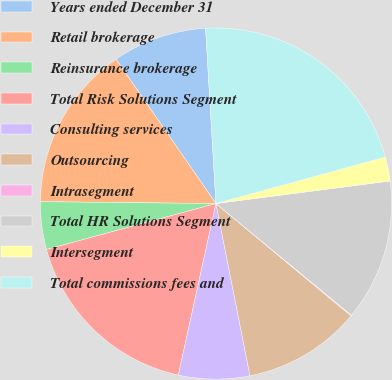Convert chart. <chart><loc_0><loc_0><loc_500><loc_500><pie_chart><fcel>Years ended December 31<fcel>Retail brokerage<fcel>Reinsurance brokerage<fcel>Total Risk Solutions Segment<fcel>Consulting services<fcel>Outsourcing<fcel>Intrasegment<fcel>Total HR Solutions Segment<fcel>Intersegment<fcel>Total commissions fees and<nl><fcel>8.7%<fcel>15.19%<fcel>4.38%<fcel>17.35%<fcel>6.54%<fcel>10.86%<fcel>0.06%<fcel>13.03%<fcel>2.22%<fcel>21.67%<nl></chart> 